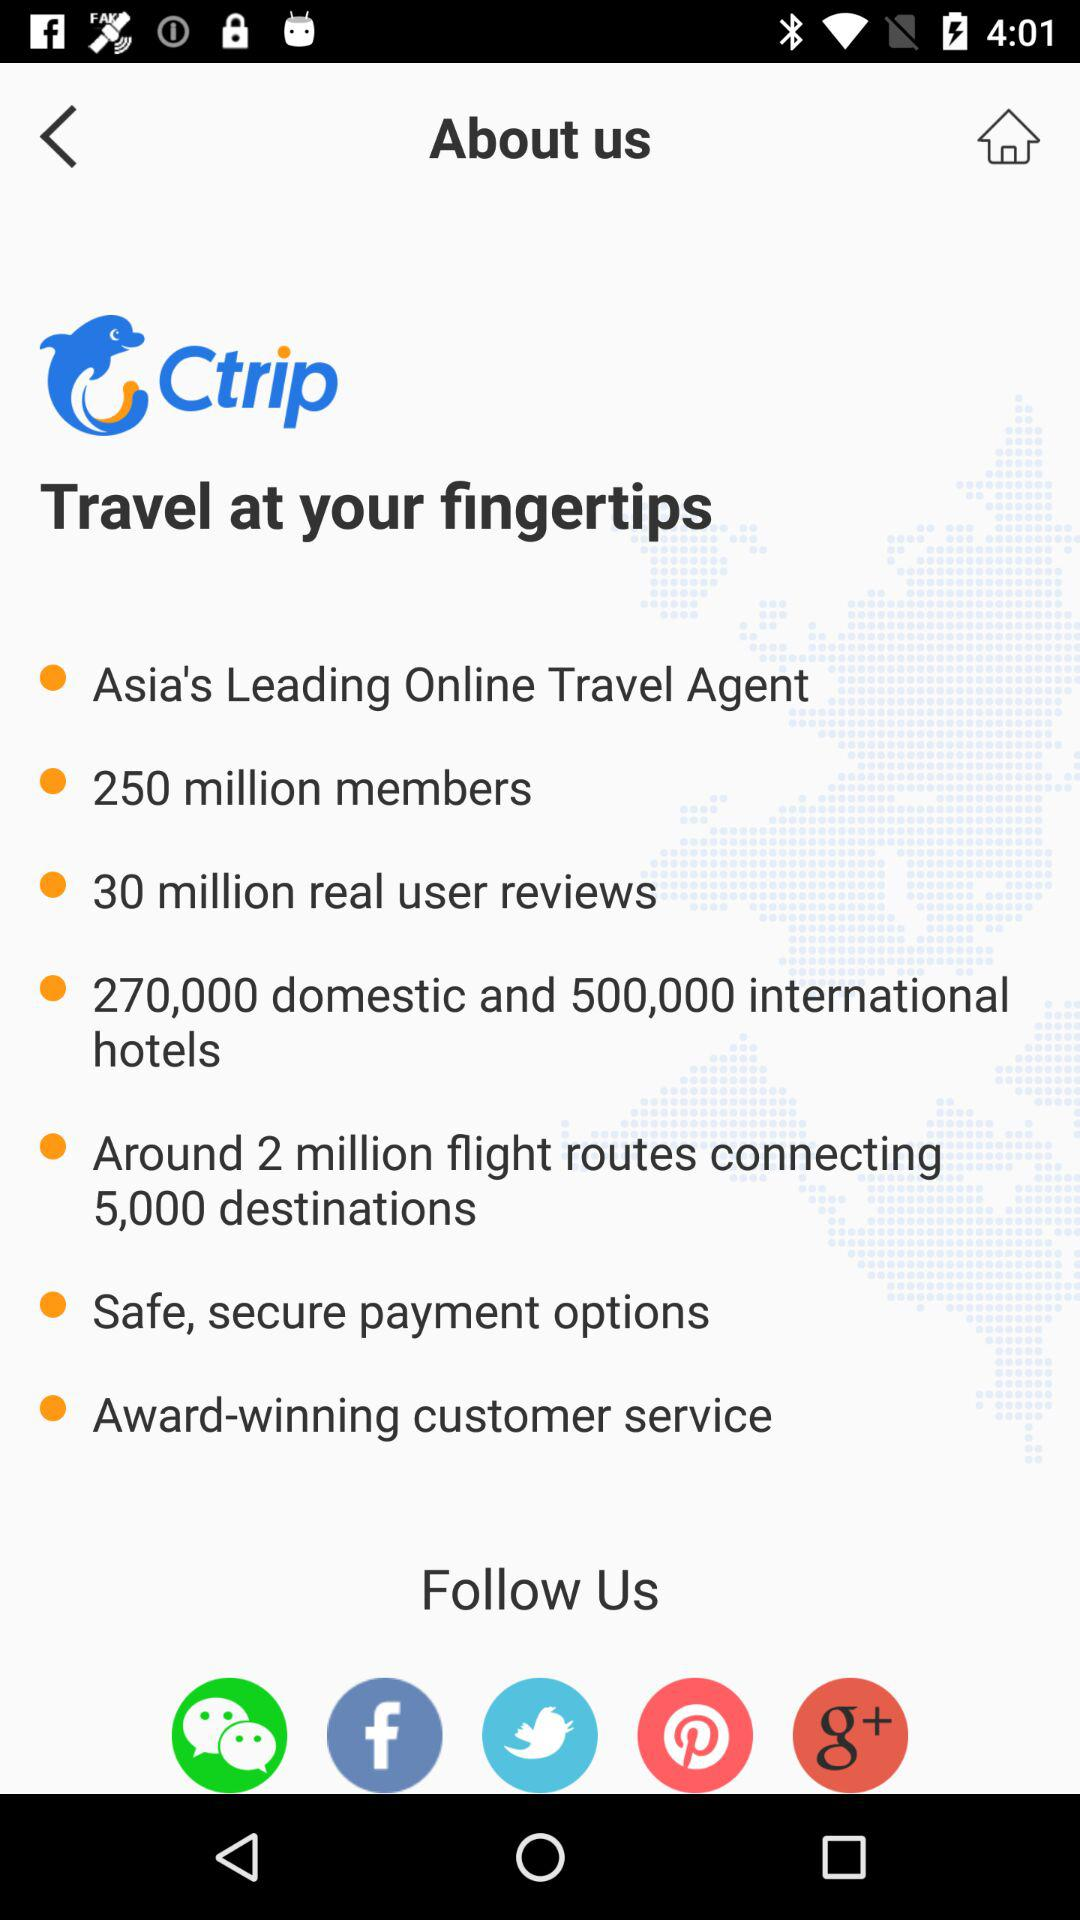What is the app's name? The app's name is "Ctrip". 